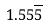<formula> <loc_0><loc_0><loc_500><loc_500>1 . 5 5 \overline { 5 }</formula> 